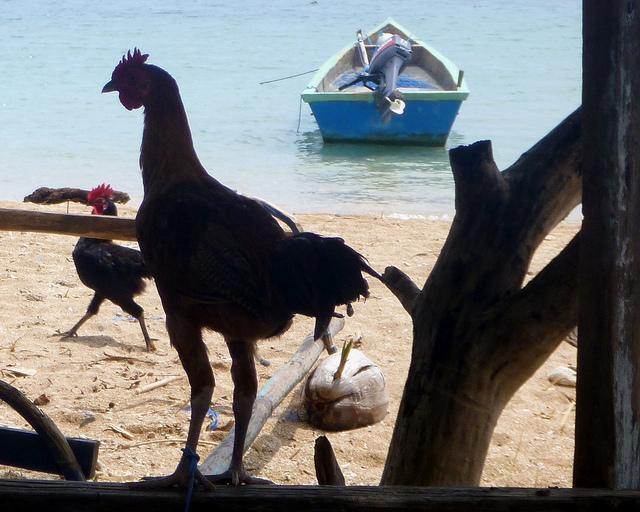How many giraffes are in the photo?
Give a very brief answer. 0. How many birds are there?
Give a very brief answer. 2. 